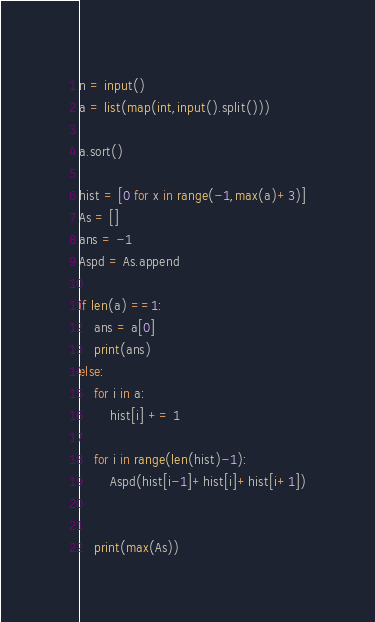<code> <loc_0><loc_0><loc_500><loc_500><_Python_>
n = input()
a = list(map(int,input().split()))

a.sort()

hist = [0 for x in range(-1,max(a)+3)]
As = []
ans = -1
Aspd = As.append

if len(a) ==1:
    ans = a[0]
    print(ans)
else:
    for i in a:
        hist[i] += 1
    
    for i in range(len(hist)-1):
        Aspd(hist[i-1]+hist[i]+hist[i+1])
        

    print(max(As))</code> 